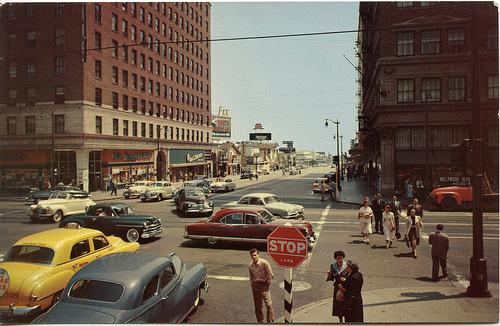Question: when was this photo taken?
Choices:
A. Recently.
B. Many years ago.
C. In the 1920s.
D. In the 1960s.
Answer with the letter. Answer: B Question: how can we tell this photo is old?
Choices:
A. It's black and white.
B. There is a date on it.
C. The cars are old.
D. People have old-fashioned clothes.
Answer with the letter. Answer: C Question: what color is the sky?
Choices:
A. White.
B. Gray.
C. Black.
D. Light blue.
Answer with the letter. Answer: D Question: why are the cars stopped?
Choices:
A. There is a traffic jam.
B. The light is red.
C. Policemen stopped them.
D. People are crossing the street.
Answer with the letter. Answer: D Question: where is this scene?
Choices:
A. A city.
B. A town.
C. The country.
D. The woods.
Answer with the letter. Answer: A 